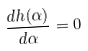Convert formula to latex. <formula><loc_0><loc_0><loc_500><loc_500>\frac { d h ( \alpha ) } { d \alpha } = 0</formula> 